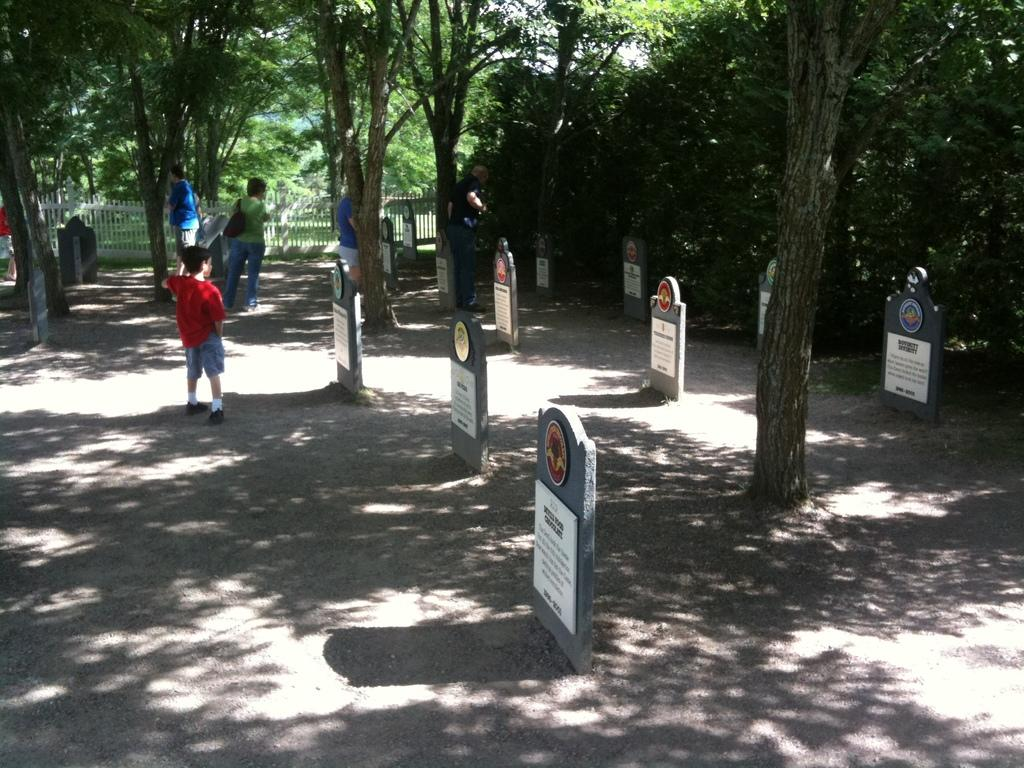Who is present in the image? There are people in the image. Where are the people located? The people are standing in a cemetery. What can be seen in the background of the image? There are trees in the image. What is the chance of rain in the image? The image does not provide any information about the weather or the chance of rain. --- Facts: 1. There is a car in the image. 2. The car is parked on the street. 3. There are buildings in the background. 4. The car has a red color. Absurd Topics: dance, ocean, guitar Conversation: What is the main subject of the image? The main subject of the image is a car. Where is the car located? The car is parked on the street. What can be seen in the background of the image? There are buildings in the background. What color is the car? A: The car has a red color. Reasoning: Let's think step by step in order to produce the conversation. We start by identifying the main subject in the image, which is the car. Then, we expand the conversation to include the location of the car, which is parked on the street. Next, we mention the presence of buildings in the background to provide additional context about the setting. Finally, we describe the color of the car, which is red. Absurd Question/Answer: Can you hear the guitar playing in the background of the image? There is no guitar or sound present in the image; it is a still photograph. 